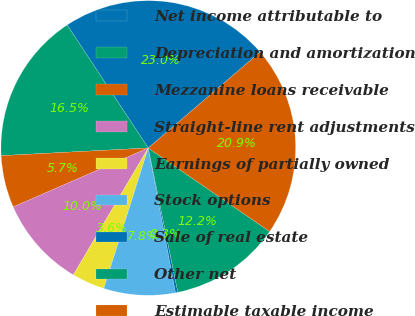<chart> <loc_0><loc_0><loc_500><loc_500><pie_chart><fcel>Net income attributable to<fcel>Depreciation and amortization<fcel>Mezzanine loans receivable<fcel>Straight-line rent adjustments<fcel>Earnings of partially owned<fcel>Stock options<fcel>Sale of real estate<fcel>Other net<fcel>Estimable taxable income<nl><fcel>23.0%<fcel>16.55%<fcel>5.72%<fcel>9.96%<fcel>3.61%<fcel>7.84%<fcel>0.26%<fcel>12.18%<fcel>20.88%<nl></chart> 